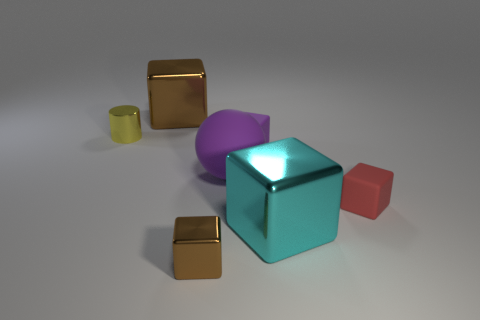Subtract all red cubes. How many cubes are left? 4 Subtract all purple rubber cubes. How many cubes are left? 4 Subtract 1 cubes. How many cubes are left? 4 Subtract all gray cubes. Subtract all red balls. How many cubes are left? 5 Add 1 small cyan metal blocks. How many objects exist? 8 Subtract all cubes. How many objects are left? 2 Add 1 blue matte spheres. How many blue matte spheres exist? 1 Subtract 1 cyan cubes. How many objects are left? 6 Subtract all tiny green matte things. Subtract all large purple things. How many objects are left? 6 Add 4 tiny blocks. How many tiny blocks are left? 7 